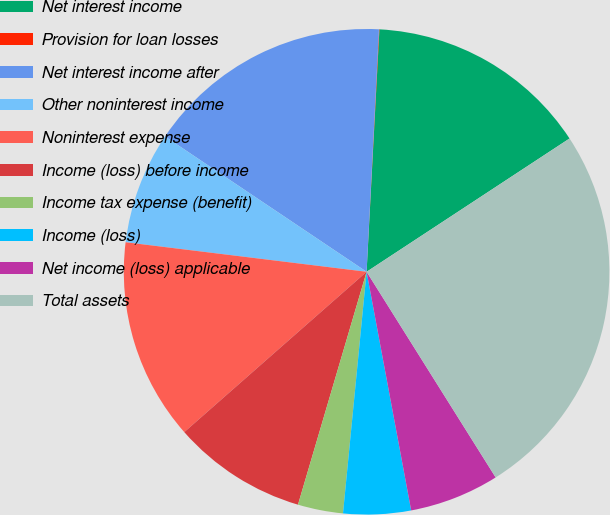<chart> <loc_0><loc_0><loc_500><loc_500><pie_chart><fcel>Net interest income<fcel>Provision for loan losses<fcel>Net interest income after<fcel>Other noninterest income<fcel>Noninterest expense<fcel>Income (loss) before income<fcel>Income tax expense (benefit)<fcel>Income (loss)<fcel>Net income (loss) applicable<fcel>Total assets<nl><fcel>14.91%<fcel>0.03%<fcel>16.4%<fcel>7.47%<fcel>13.42%<fcel>8.96%<fcel>3.01%<fcel>4.49%<fcel>5.98%<fcel>25.33%<nl></chart> 